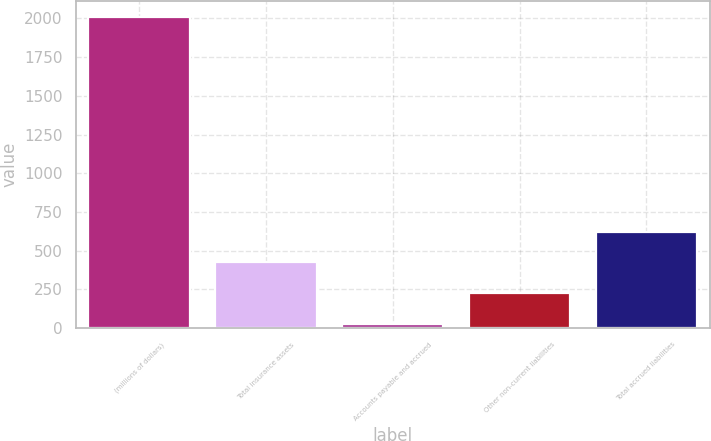Convert chart. <chart><loc_0><loc_0><loc_500><loc_500><bar_chart><fcel>(millions of dollars)<fcel>Total insurance assets<fcel>Accounts payable and accrued<fcel>Other non-current liabilities<fcel>Total accrued liabilities<nl><fcel>2011<fcel>425.24<fcel>28.8<fcel>227.02<fcel>623.46<nl></chart> 